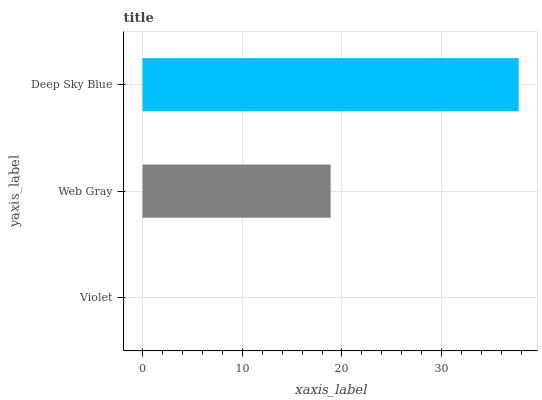Is Violet the minimum?
Answer yes or no. Yes. Is Deep Sky Blue the maximum?
Answer yes or no. Yes. Is Web Gray the minimum?
Answer yes or no. No. Is Web Gray the maximum?
Answer yes or no. No. Is Web Gray greater than Violet?
Answer yes or no. Yes. Is Violet less than Web Gray?
Answer yes or no. Yes. Is Violet greater than Web Gray?
Answer yes or no. No. Is Web Gray less than Violet?
Answer yes or no. No. Is Web Gray the high median?
Answer yes or no. Yes. Is Web Gray the low median?
Answer yes or no. Yes. Is Violet the high median?
Answer yes or no. No. Is Deep Sky Blue the low median?
Answer yes or no. No. 